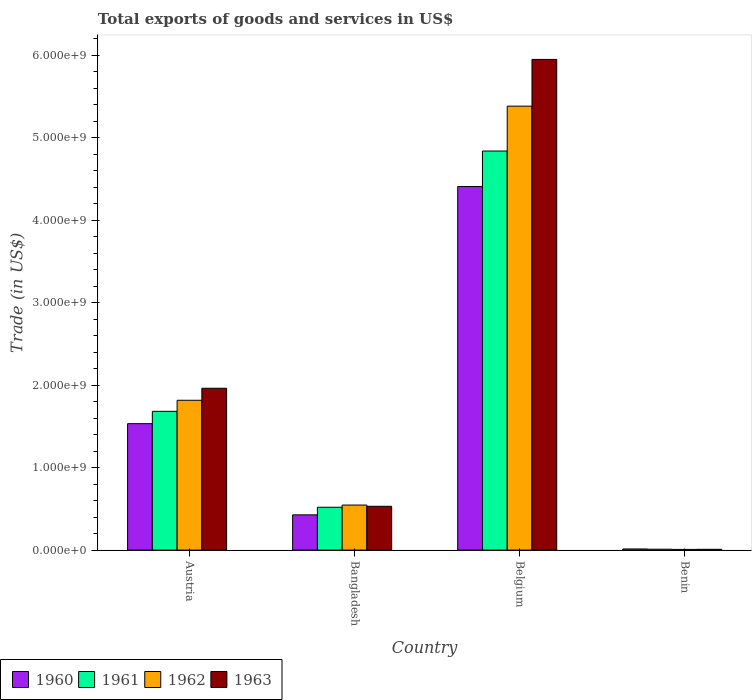How many different coloured bars are there?
Make the answer very short. 4. How many groups of bars are there?
Your answer should be compact. 4. Are the number of bars on each tick of the X-axis equal?
Provide a succinct answer. Yes. How many bars are there on the 2nd tick from the left?
Offer a terse response. 4. How many bars are there on the 4th tick from the right?
Your answer should be very brief. 4. What is the total exports of goods and services in 1961 in Austria?
Provide a short and direct response. 1.68e+09. Across all countries, what is the maximum total exports of goods and services in 1963?
Give a very brief answer. 5.95e+09. Across all countries, what is the minimum total exports of goods and services in 1962?
Ensure brevity in your answer.  8.32e+06. In which country was the total exports of goods and services in 1961 minimum?
Provide a succinct answer. Benin. What is the total total exports of goods and services in 1960 in the graph?
Give a very brief answer. 6.38e+09. What is the difference between the total exports of goods and services in 1962 in Belgium and that in Benin?
Provide a short and direct response. 5.37e+09. What is the difference between the total exports of goods and services in 1962 in Benin and the total exports of goods and services in 1960 in Austria?
Offer a terse response. -1.52e+09. What is the average total exports of goods and services in 1962 per country?
Ensure brevity in your answer.  1.94e+09. What is the difference between the total exports of goods and services of/in 1963 and total exports of goods and services of/in 1960 in Belgium?
Give a very brief answer. 1.54e+09. What is the ratio of the total exports of goods and services in 1960 in Belgium to that in Benin?
Your answer should be compact. 318.15. What is the difference between the highest and the second highest total exports of goods and services in 1962?
Your answer should be very brief. 4.84e+09. What is the difference between the highest and the lowest total exports of goods and services in 1963?
Provide a short and direct response. 5.94e+09. In how many countries, is the total exports of goods and services in 1961 greater than the average total exports of goods and services in 1961 taken over all countries?
Your response must be concise. 1. Is the sum of the total exports of goods and services in 1961 in Austria and Belgium greater than the maximum total exports of goods and services in 1963 across all countries?
Give a very brief answer. Yes. How many bars are there?
Make the answer very short. 16. Are all the bars in the graph horizontal?
Offer a terse response. No. How many countries are there in the graph?
Ensure brevity in your answer.  4. Does the graph contain any zero values?
Provide a short and direct response. No. Does the graph contain grids?
Give a very brief answer. No. What is the title of the graph?
Keep it short and to the point. Total exports of goods and services in US$. Does "1965" appear as one of the legend labels in the graph?
Provide a short and direct response. No. What is the label or title of the X-axis?
Make the answer very short. Country. What is the label or title of the Y-axis?
Provide a succinct answer. Trade (in US$). What is the Trade (in US$) of 1960 in Austria?
Offer a very short reply. 1.53e+09. What is the Trade (in US$) in 1961 in Austria?
Your response must be concise. 1.68e+09. What is the Trade (in US$) in 1962 in Austria?
Offer a very short reply. 1.82e+09. What is the Trade (in US$) of 1963 in Austria?
Give a very brief answer. 1.96e+09. What is the Trade (in US$) of 1960 in Bangladesh?
Provide a short and direct response. 4.27e+08. What is the Trade (in US$) of 1961 in Bangladesh?
Ensure brevity in your answer.  5.19e+08. What is the Trade (in US$) in 1962 in Bangladesh?
Provide a short and direct response. 5.46e+08. What is the Trade (in US$) of 1963 in Bangladesh?
Give a very brief answer. 5.31e+08. What is the Trade (in US$) in 1960 in Belgium?
Keep it short and to the point. 4.41e+09. What is the Trade (in US$) in 1961 in Belgium?
Provide a short and direct response. 4.84e+09. What is the Trade (in US$) of 1962 in Belgium?
Your answer should be compact. 5.38e+09. What is the Trade (in US$) in 1963 in Belgium?
Keep it short and to the point. 5.95e+09. What is the Trade (in US$) of 1960 in Benin?
Keep it short and to the point. 1.39e+07. What is the Trade (in US$) in 1961 in Benin?
Provide a succinct answer. 1.08e+07. What is the Trade (in US$) of 1962 in Benin?
Offer a terse response. 8.32e+06. What is the Trade (in US$) in 1963 in Benin?
Offer a very short reply. 9.70e+06. Across all countries, what is the maximum Trade (in US$) in 1960?
Provide a succinct answer. 4.41e+09. Across all countries, what is the maximum Trade (in US$) of 1961?
Your answer should be very brief. 4.84e+09. Across all countries, what is the maximum Trade (in US$) of 1962?
Provide a short and direct response. 5.38e+09. Across all countries, what is the maximum Trade (in US$) of 1963?
Your answer should be compact. 5.95e+09. Across all countries, what is the minimum Trade (in US$) in 1960?
Offer a terse response. 1.39e+07. Across all countries, what is the minimum Trade (in US$) of 1961?
Give a very brief answer. 1.08e+07. Across all countries, what is the minimum Trade (in US$) of 1962?
Your answer should be compact. 8.32e+06. Across all countries, what is the minimum Trade (in US$) in 1963?
Your answer should be compact. 9.70e+06. What is the total Trade (in US$) in 1960 in the graph?
Your answer should be compact. 6.38e+09. What is the total Trade (in US$) in 1961 in the graph?
Offer a very short reply. 7.05e+09. What is the total Trade (in US$) in 1962 in the graph?
Keep it short and to the point. 7.75e+09. What is the total Trade (in US$) of 1963 in the graph?
Provide a succinct answer. 8.45e+09. What is the difference between the Trade (in US$) in 1960 in Austria and that in Bangladesh?
Your answer should be compact. 1.11e+09. What is the difference between the Trade (in US$) in 1961 in Austria and that in Bangladesh?
Give a very brief answer. 1.16e+09. What is the difference between the Trade (in US$) in 1962 in Austria and that in Bangladesh?
Your answer should be very brief. 1.27e+09. What is the difference between the Trade (in US$) in 1963 in Austria and that in Bangladesh?
Make the answer very short. 1.43e+09. What is the difference between the Trade (in US$) in 1960 in Austria and that in Belgium?
Make the answer very short. -2.87e+09. What is the difference between the Trade (in US$) in 1961 in Austria and that in Belgium?
Make the answer very short. -3.16e+09. What is the difference between the Trade (in US$) of 1962 in Austria and that in Belgium?
Keep it short and to the point. -3.57e+09. What is the difference between the Trade (in US$) in 1963 in Austria and that in Belgium?
Make the answer very short. -3.99e+09. What is the difference between the Trade (in US$) in 1960 in Austria and that in Benin?
Provide a short and direct response. 1.52e+09. What is the difference between the Trade (in US$) of 1961 in Austria and that in Benin?
Your answer should be very brief. 1.67e+09. What is the difference between the Trade (in US$) of 1962 in Austria and that in Benin?
Provide a succinct answer. 1.81e+09. What is the difference between the Trade (in US$) of 1963 in Austria and that in Benin?
Your response must be concise. 1.95e+09. What is the difference between the Trade (in US$) in 1960 in Bangladesh and that in Belgium?
Make the answer very short. -3.98e+09. What is the difference between the Trade (in US$) of 1961 in Bangladesh and that in Belgium?
Your answer should be very brief. -4.32e+09. What is the difference between the Trade (in US$) in 1962 in Bangladesh and that in Belgium?
Offer a very short reply. -4.84e+09. What is the difference between the Trade (in US$) in 1963 in Bangladesh and that in Belgium?
Keep it short and to the point. -5.42e+09. What is the difference between the Trade (in US$) in 1960 in Bangladesh and that in Benin?
Offer a very short reply. 4.13e+08. What is the difference between the Trade (in US$) of 1961 in Bangladesh and that in Benin?
Keep it short and to the point. 5.09e+08. What is the difference between the Trade (in US$) of 1962 in Bangladesh and that in Benin?
Provide a short and direct response. 5.38e+08. What is the difference between the Trade (in US$) in 1963 in Bangladesh and that in Benin?
Offer a very short reply. 5.21e+08. What is the difference between the Trade (in US$) of 1960 in Belgium and that in Benin?
Give a very brief answer. 4.39e+09. What is the difference between the Trade (in US$) in 1961 in Belgium and that in Benin?
Offer a terse response. 4.83e+09. What is the difference between the Trade (in US$) of 1962 in Belgium and that in Benin?
Provide a succinct answer. 5.37e+09. What is the difference between the Trade (in US$) of 1963 in Belgium and that in Benin?
Your response must be concise. 5.94e+09. What is the difference between the Trade (in US$) in 1960 in Austria and the Trade (in US$) in 1961 in Bangladesh?
Keep it short and to the point. 1.01e+09. What is the difference between the Trade (in US$) in 1960 in Austria and the Trade (in US$) in 1962 in Bangladesh?
Your answer should be compact. 9.87e+08. What is the difference between the Trade (in US$) of 1960 in Austria and the Trade (in US$) of 1963 in Bangladesh?
Provide a short and direct response. 1.00e+09. What is the difference between the Trade (in US$) of 1961 in Austria and the Trade (in US$) of 1962 in Bangladesh?
Your answer should be very brief. 1.14e+09. What is the difference between the Trade (in US$) of 1961 in Austria and the Trade (in US$) of 1963 in Bangladesh?
Provide a succinct answer. 1.15e+09. What is the difference between the Trade (in US$) of 1962 in Austria and the Trade (in US$) of 1963 in Bangladesh?
Your response must be concise. 1.29e+09. What is the difference between the Trade (in US$) in 1960 in Austria and the Trade (in US$) in 1961 in Belgium?
Keep it short and to the point. -3.31e+09. What is the difference between the Trade (in US$) in 1960 in Austria and the Trade (in US$) in 1962 in Belgium?
Offer a terse response. -3.85e+09. What is the difference between the Trade (in US$) in 1960 in Austria and the Trade (in US$) in 1963 in Belgium?
Your answer should be very brief. -4.42e+09. What is the difference between the Trade (in US$) of 1961 in Austria and the Trade (in US$) of 1962 in Belgium?
Make the answer very short. -3.70e+09. What is the difference between the Trade (in US$) in 1961 in Austria and the Trade (in US$) in 1963 in Belgium?
Ensure brevity in your answer.  -4.27e+09. What is the difference between the Trade (in US$) in 1962 in Austria and the Trade (in US$) in 1963 in Belgium?
Your answer should be compact. -4.13e+09. What is the difference between the Trade (in US$) of 1960 in Austria and the Trade (in US$) of 1961 in Benin?
Offer a terse response. 1.52e+09. What is the difference between the Trade (in US$) in 1960 in Austria and the Trade (in US$) in 1962 in Benin?
Offer a terse response. 1.52e+09. What is the difference between the Trade (in US$) of 1960 in Austria and the Trade (in US$) of 1963 in Benin?
Offer a very short reply. 1.52e+09. What is the difference between the Trade (in US$) of 1961 in Austria and the Trade (in US$) of 1962 in Benin?
Make the answer very short. 1.67e+09. What is the difference between the Trade (in US$) of 1961 in Austria and the Trade (in US$) of 1963 in Benin?
Make the answer very short. 1.67e+09. What is the difference between the Trade (in US$) of 1962 in Austria and the Trade (in US$) of 1963 in Benin?
Your answer should be very brief. 1.81e+09. What is the difference between the Trade (in US$) in 1960 in Bangladesh and the Trade (in US$) in 1961 in Belgium?
Your answer should be very brief. -4.41e+09. What is the difference between the Trade (in US$) of 1960 in Bangladesh and the Trade (in US$) of 1962 in Belgium?
Offer a terse response. -4.95e+09. What is the difference between the Trade (in US$) in 1960 in Bangladesh and the Trade (in US$) in 1963 in Belgium?
Ensure brevity in your answer.  -5.52e+09. What is the difference between the Trade (in US$) in 1961 in Bangladesh and the Trade (in US$) in 1962 in Belgium?
Provide a succinct answer. -4.86e+09. What is the difference between the Trade (in US$) of 1961 in Bangladesh and the Trade (in US$) of 1963 in Belgium?
Your answer should be very brief. -5.43e+09. What is the difference between the Trade (in US$) in 1962 in Bangladesh and the Trade (in US$) in 1963 in Belgium?
Your answer should be very brief. -5.40e+09. What is the difference between the Trade (in US$) of 1960 in Bangladesh and the Trade (in US$) of 1961 in Benin?
Make the answer very short. 4.17e+08. What is the difference between the Trade (in US$) of 1960 in Bangladesh and the Trade (in US$) of 1962 in Benin?
Provide a succinct answer. 4.19e+08. What is the difference between the Trade (in US$) of 1960 in Bangladesh and the Trade (in US$) of 1963 in Benin?
Your answer should be very brief. 4.18e+08. What is the difference between the Trade (in US$) in 1961 in Bangladesh and the Trade (in US$) in 1962 in Benin?
Provide a succinct answer. 5.11e+08. What is the difference between the Trade (in US$) in 1961 in Bangladesh and the Trade (in US$) in 1963 in Benin?
Your response must be concise. 5.10e+08. What is the difference between the Trade (in US$) in 1962 in Bangladesh and the Trade (in US$) in 1963 in Benin?
Offer a very short reply. 5.36e+08. What is the difference between the Trade (in US$) in 1960 in Belgium and the Trade (in US$) in 1961 in Benin?
Offer a very short reply. 4.40e+09. What is the difference between the Trade (in US$) in 1960 in Belgium and the Trade (in US$) in 1962 in Benin?
Your response must be concise. 4.40e+09. What is the difference between the Trade (in US$) of 1960 in Belgium and the Trade (in US$) of 1963 in Benin?
Your answer should be very brief. 4.40e+09. What is the difference between the Trade (in US$) in 1961 in Belgium and the Trade (in US$) in 1962 in Benin?
Your response must be concise. 4.83e+09. What is the difference between the Trade (in US$) in 1961 in Belgium and the Trade (in US$) in 1963 in Benin?
Provide a short and direct response. 4.83e+09. What is the difference between the Trade (in US$) of 1962 in Belgium and the Trade (in US$) of 1963 in Benin?
Ensure brevity in your answer.  5.37e+09. What is the average Trade (in US$) of 1960 per country?
Provide a short and direct response. 1.60e+09. What is the average Trade (in US$) in 1961 per country?
Ensure brevity in your answer.  1.76e+09. What is the average Trade (in US$) in 1962 per country?
Your response must be concise. 1.94e+09. What is the average Trade (in US$) of 1963 per country?
Your answer should be compact. 2.11e+09. What is the difference between the Trade (in US$) in 1960 and Trade (in US$) in 1961 in Austria?
Your answer should be very brief. -1.49e+08. What is the difference between the Trade (in US$) of 1960 and Trade (in US$) of 1962 in Austria?
Your response must be concise. -2.84e+08. What is the difference between the Trade (in US$) of 1960 and Trade (in US$) of 1963 in Austria?
Ensure brevity in your answer.  -4.29e+08. What is the difference between the Trade (in US$) in 1961 and Trade (in US$) in 1962 in Austria?
Offer a very short reply. -1.34e+08. What is the difference between the Trade (in US$) in 1961 and Trade (in US$) in 1963 in Austria?
Ensure brevity in your answer.  -2.80e+08. What is the difference between the Trade (in US$) in 1962 and Trade (in US$) in 1963 in Austria?
Ensure brevity in your answer.  -1.46e+08. What is the difference between the Trade (in US$) in 1960 and Trade (in US$) in 1961 in Bangladesh?
Keep it short and to the point. -9.21e+07. What is the difference between the Trade (in US$) in 1960 and Trade (in US$) in 1962 in Bangladesh?
Keep it short and to the point. -1.19e+08. What is the difference between the Trade (in US$) of 1960 and Trade (in US$) of 1963 in Bangladesh?
Give a very brief answer. -1.04e+08. What is the difference between the Trade (in US$) of 1961 and Trade (in US$) of 1962 in Bangladesh?
Ensure brevity in your answer.  -2.66e+07. What is the difference between the Trade (in US$) of 1961 and Trade (in US$) of 1963 in Bangladesh?
Your answer should be compact. -1.16e+07. What is the difference between the Trade (in US$) in 1962 and Trade (in US$) in 1963 in Bangladesh?
Make the answer very short. 1.50e+07. What is the difference between the Trade (in US$) in 1960 and Trade (in US$) in 1961 in Belgium?
Your answer should be very brief. -4.31e+08. What is the difference between the Trade (in US$) in 1960 and Trade (in US$) in 1962 in Belgium?
Give a very brief answer. -9.75e+08. What is the difference between the Trade (in US$) of 1960 and Trade (in US$) of 1963 in Belgium?
Offer a very short reply. -1.54e+09. What is the difference between the Trade (in US$) in 1961 and Trade (in US$) in 1962 in Belgium?
Keep it short and to the point. -5.44e+08. What is the difference between the Trade (in US$) of 1961 and Trade (in US$) of 1963 in Belgium?
Provide a succinct answer. -1.11e+09. What is the difference between the Trade (in US$) of 1962 and Trade (in US$) of 1963 in Belgium?
Ensure brevity in your answer.  -5.67e+08. What is the difference between the Trade (in US$) of 1960 and Trade (in US$) of 1961 in Benin?
Your answer should be compact. 3.05e+06. What is the difference between the Trade (in US$) of 1960 and Trade (in US$) of 1962 in Benin?
Ensure brevity in your answer.  5.53e+06. What is the difference between the Trade (in US$) in 1960 and Trade (in US$) in 1963 in Benin?
Offer a terse response. 4.15e+06. What is the difference between the Trade (in US$) of 1961 and Trade (in US$) of 1962 in Benin?
Offer a terse response. 2.48e+06. What is the difference between the Trade (in US$) in 1961 and Trade (in US$) in 1963 in Benin?
Your answer should be compact. 1.10e+06. What is the difference between the Trade (in US$) of 1962 and Trade (in US$) of 1963 in Benin?
Give a very brief answer. -1.39e+06. What is the ratio of the Trade (in US$) of 1960 in Austria to that in Bangladesh?
Offer a very short reply. 3.59. What is the ratio of the Trade (in US$) of 1961 in Austria to that in Bangladesh?
Provide a succinct answer. 3.24. What is the ratio of the Trade (in US$) of 1962 in Austria to that in Bangladesh?
Ensure brevity in your answer.  3.33. What is the ratio of the Trade (in US$) of 1963 in Austria to that in Bangladesh?
Offer a terse response. 3.69. What is the ratio of the Trade (in US$) in 1960 in Austria to that in Belgium?
Ensure brevity in your answer.  0.35. What is the ratio of the Trade (in US$) of 1961 in Austria to that in Belgium?
Your response must be concise. 0.35. What is the ratio of the Trade (in US$) of 1962 in Austria to that in Belgium?
Ensure brevity in your answer.  0.34. What is the ratio of the Trade (in US$) of 1963 in Austria to that in Belgium?
Ensure brevity in your answer.  0.33. What is the ratio of the Trade (in US$) of 1960 in Austria to that in Benin?
Your answer should be very brief. 110.65. What is the ratio of the Trade (in US$) in 1961 in Austria to that in Benin?
Keep it short and to the point. 155.72. What is the ratio of the Trade (in US$) in 1962 in Austria to that in Benin?
Provide a short and direct response. 218.36. What is the ratio of the Trade (in US$) in 1963 in Austria to that in Benin?
Give a very brief answer. 202.17. What is the ratio of the Trade (in US$) in 1960 in Bangladesh to that in Belgium?
Give a very brief answer. 0.1. What is the ratio of the Trade (in US$) of 1961 in Bangladesh to that in Belgium?
Ensure brevity in your answer.  0.11. What is the ratio of the Trade (in US$) of 1962 in Bangladesh to that in Belgium?
Ensure brevity in your answer.  0.1. What is the ratio of the Trade (in US$) of 1963 in Bangladesh to that in Belgium?
Offer a terse response. 0.09. What is the ratio of the Trade (in US$) of 1960 in Bangladesh to that in Benin?
Your answer should be very brief. 30.85. What is the ratio of the Trade (in US$) of 1961 in Bangladesh to that in Benin?
Give a very brief answer. 48.09. What is the ratio of the Trade (in US$) of 1962 in Bangladesh to that in Benin?
Make the answer very short. 65.66. What is the ratio of the Trade (in US$) in 1963 in Bangladesh to that in Benin?
Offer a very short reply. 54.73. What is the ratio of the Trade (in US$) of 1960 in Belgium to that in Benin?
Ensure brevity in your answer.  318.15. What is the ratio of the Trade (in US$) in 1961 in Belgium to that in Benin?
Keep it short and to the point. 447.86. What is the ratio of the Trade (in US$) in 1962 in Belgium to that in Benin?
Keep it short and to the point. 647.03. What is the ratio of the Trade (in US$) in 1963 in Belgium to that in Benin?
Give a very brief answer. 613. What is the difference between the highest and the second highest Trade (in US$) in 1960?
Your answer should be compact. 2.87e+09. What is the difference between the highest and the second highest Trade (in US$) of 1961?
Keep it short and to the point. 3.16e+09. What is the difference between the highest and the second highest Trade (in US$) in 1962?
Your answer should be very brief. 3.57e+09. What is the difference between the highest and the second highest Trade (in US$) of 1963?
Your answer should be very brief. 3.99e+09. What is the difference between the highest and the lowest Trade (in US$) in 1960?
Provide a succinct answer. 4.39e+09. What is the difference between the highest and the lowest Trade (in US$) in 1961?
Give a very brief answer. 4.83e+09. What is the difference between the highest and the lowest Trade (in US$) in 1962?
Provide a succinct answer. 5.37e+09. What is the difference between the highest and the lowest Trade (in US$) in 1963?
Your response must be concise. 5.94e+09. 